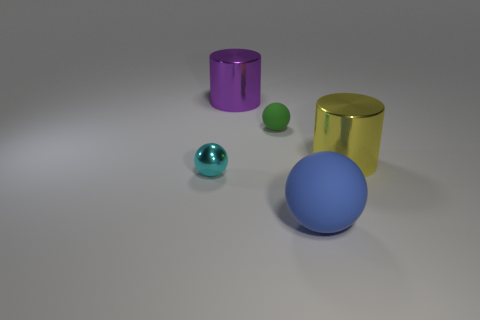Is there anything else that has the same material as the large blue thing?
Your answer should be very brief. Yes. What number of things are big cylinders to the right of the big blue rubber ball or small balls?
Provide a succinct answer. 3. There is a big metal cylinder that is to the right of the rubber sphere in front of the small shiny ball; are there any yellow shiny cylinders that are on the right side of it?
Keep it short and to the point. No. What number of tiny metallic objects are there?
Your answer should be very brief. 1. What number of things are large shiny objects to the left of the big blue object or rubber objects that are in front of the tiny cyan shiny object?
Keep it short and to the point. 2. There is a cylinder to the left of the blue object; does it have the same size as the large ball?
Offer a very short reply. Yes. What size is the green thing that is the same shape as the big blue rubber object?
Ensure brevity in your answer.  Small. There is a purple cylinder that is the same size as the blue matte thing; what is it made of?
Offer a very short reply. Metal. What material is the yellow thing that is the same shape as the large purple object?
Your answer should be very brief. Metal. How many other objects are there of the same size as the green rubber object?
Provide a succinct answer. 1. 